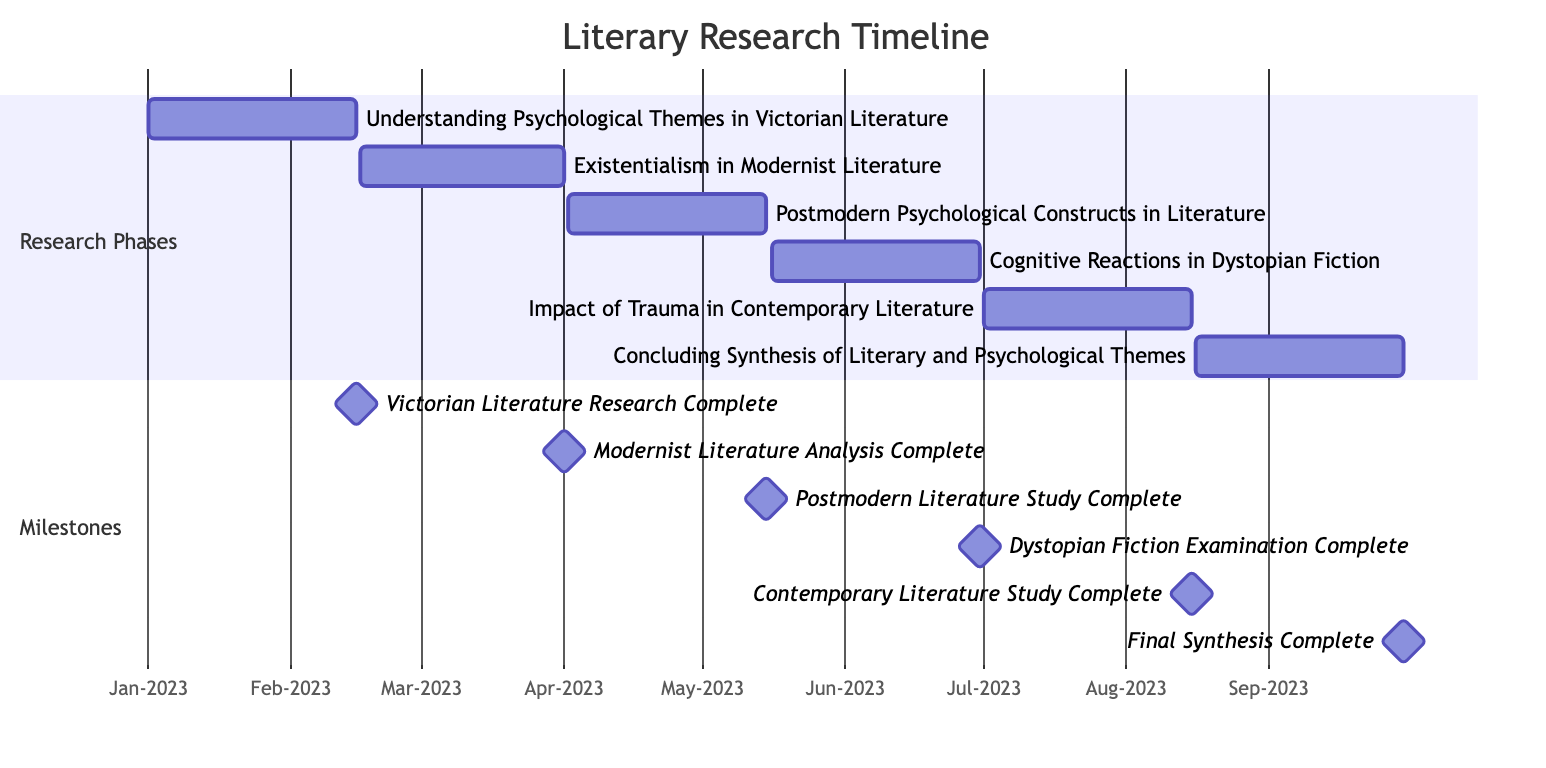What is the first research phase? The diagram lists various research phases, and the first one in chronological order starts on January 1, 2023. The title of the first phase is "Understanding Psychological Themes in Victorian Literature."
Answer: Understanding Psychological Themes in Victorian Literature How many research phases are depicted in the chart? By counting the sections in the diagram, there are a total of six different research phases listed, each focusing on a distinct theme.
Answer: 6 What is the end date for the "Existentialism in Modernist Literature" phase? The diagram clearly marks the end date for this phase, which shows the date as April 1, 2023.
Answer: 2023-04-01 Which research phase ends on June 30, 2023? The phase that concludes on June 30, 2023, is identified as "Cognitive Reactions in Dystopian Fiction," as per the timeline layout displayed in the diagram.
Answer: Cognitive Reactions in Dystopian Fiction What is the milestone that follows the completion of "Impact of Trauma in Contemporary Literature"? By reviewing the order of milestones, the one that follows this phase and is the next milestone is "Final Synthesis Complete." This can be seen from the timing of their respective completion dates in the diagram.
Answer: Final Synthesis Complete Which research phase has the longest duration? The durations for each phase can be calculated based on their start and end dates. The phase "Cognitive Reactions in Dystopian Fiction" spans from May 16, 2023, to June 30, 2023, making it the longest at 45 days.
Answer: Cognitive Reactions in Dystopian Fiction What is the overall theme of the research represented in this Gantt chart? The chart focuses on the exploration of literary works through the lens of psychology, with each phase addressing specific themes linking literature and psychological concepts.
Answer: Literary and psychological themes How many milestones are shown in the chart? The chart shows a total of six milestones, each marking the completion of a corresponding research phase within the timeline structure.
Answer: 6 